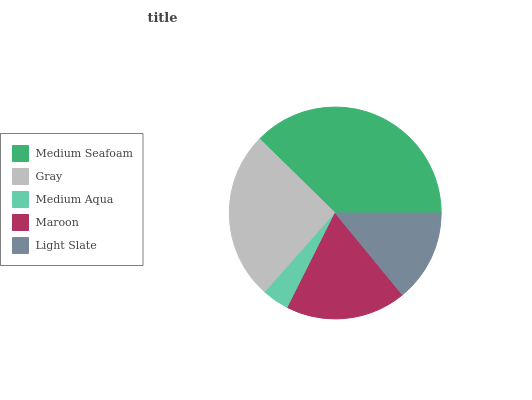Is Medium Aqua the minimum?
Answer yes or no. Yes. Is Medium Seafoam the maximum?
Answer yes or no. Yes. Is Gray the minimum?
Answer yes or no. No. Is Gray the maximum?
Answer yes or no. No. Is Medium Seafoam greater than Gray?
Answer yes or no. Yes. Is Gray less than Medium Seafoam?
Answer yes or no. Yes. Is Gray greater than Medium Seafoam?
Answer yes or no. No. Is Medium Seafoam less than Gray?
Answer yes or no. No. Is Maroon the high median?
Answer yes or no. Yes. Is Maroon the low median?
Answer yes or no. Yes. Is Medium Aqua the high median?
Answer yes or no. No. Is Medium Seafoam the low median?
Answer yes or no. No. 